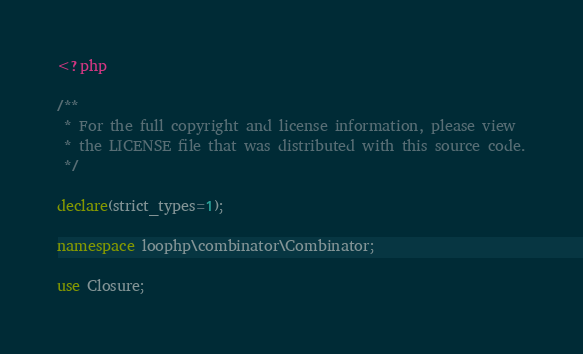Convert code to text. <code><loc_0><loc_0><loc_500><loc_500><_PHP_><?php

/**
 * For the full copyright and license information, please view
 * the LICENSE file that was distributed with this source code.
 */

declare(strict_types=1);

namespace loophp\combinator\Combinator;

use Closure;</code> 